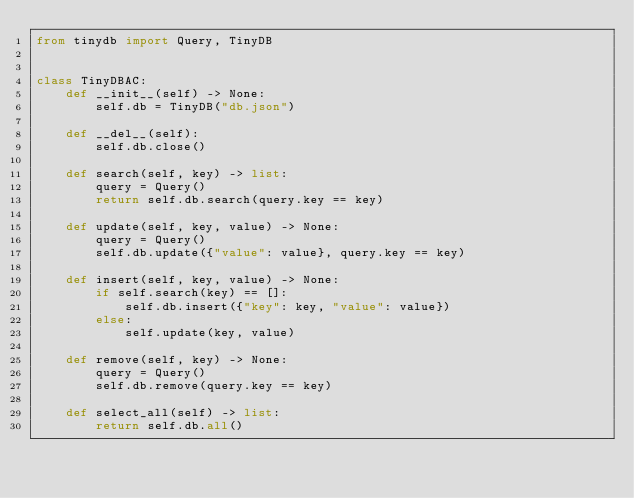Convert code to text. <code><loc_0><loc_0><loc_500><loc_500><_Python_>from tinydb import Query, TinyDB


class TinyDBAC:
    def __init__(self) -> None:
        self.db = TinyDB("db.json")

    def __del__(self):
        self.db.close()

    def search(self, key) -> list:
        query = Query()
        return self.db.search(query.key == key)

    def update(self, key, value) -> None:
        query = Query()
        self.db.update({"value": value}, query.key == key)

    def insert(self, key, value) -> None:
        if self.search(key) == []:
            self.db.insert({"key": key, "value": value})
        else:
            self.update(key, value)

    def remove(self, key) -> None:
        query = Query()
        self.db.remove(query.key == key)

    def select_all(self) -> list:
        return self.db.all()
</code> 